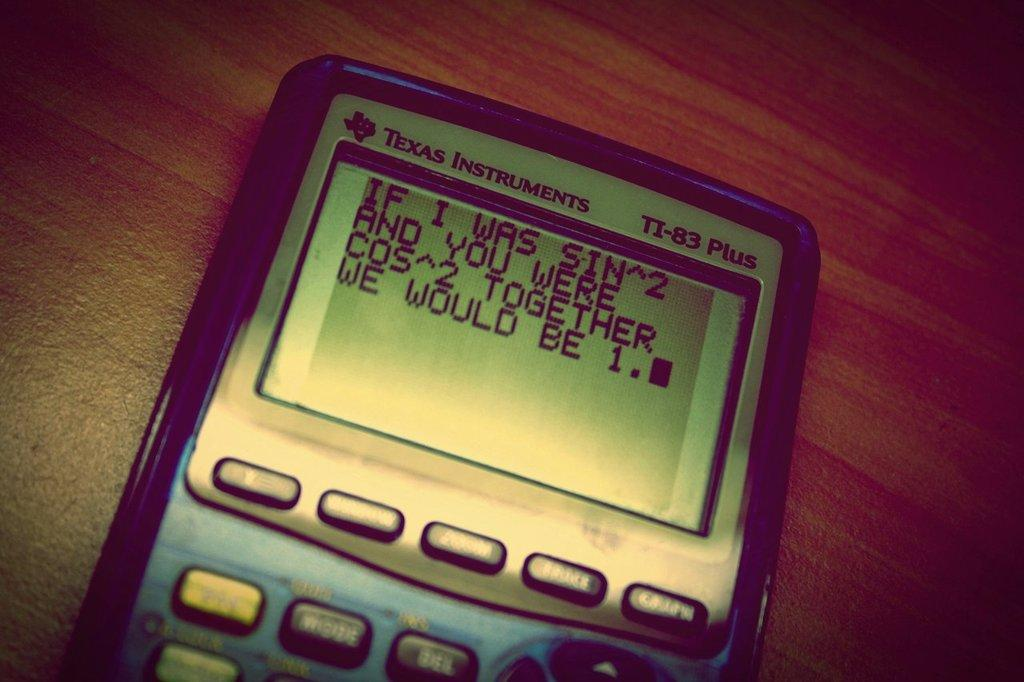<image>
Relay a brief, clear account of the picture shown. A Texas Instruments calculator has a joke written out on the screen. 